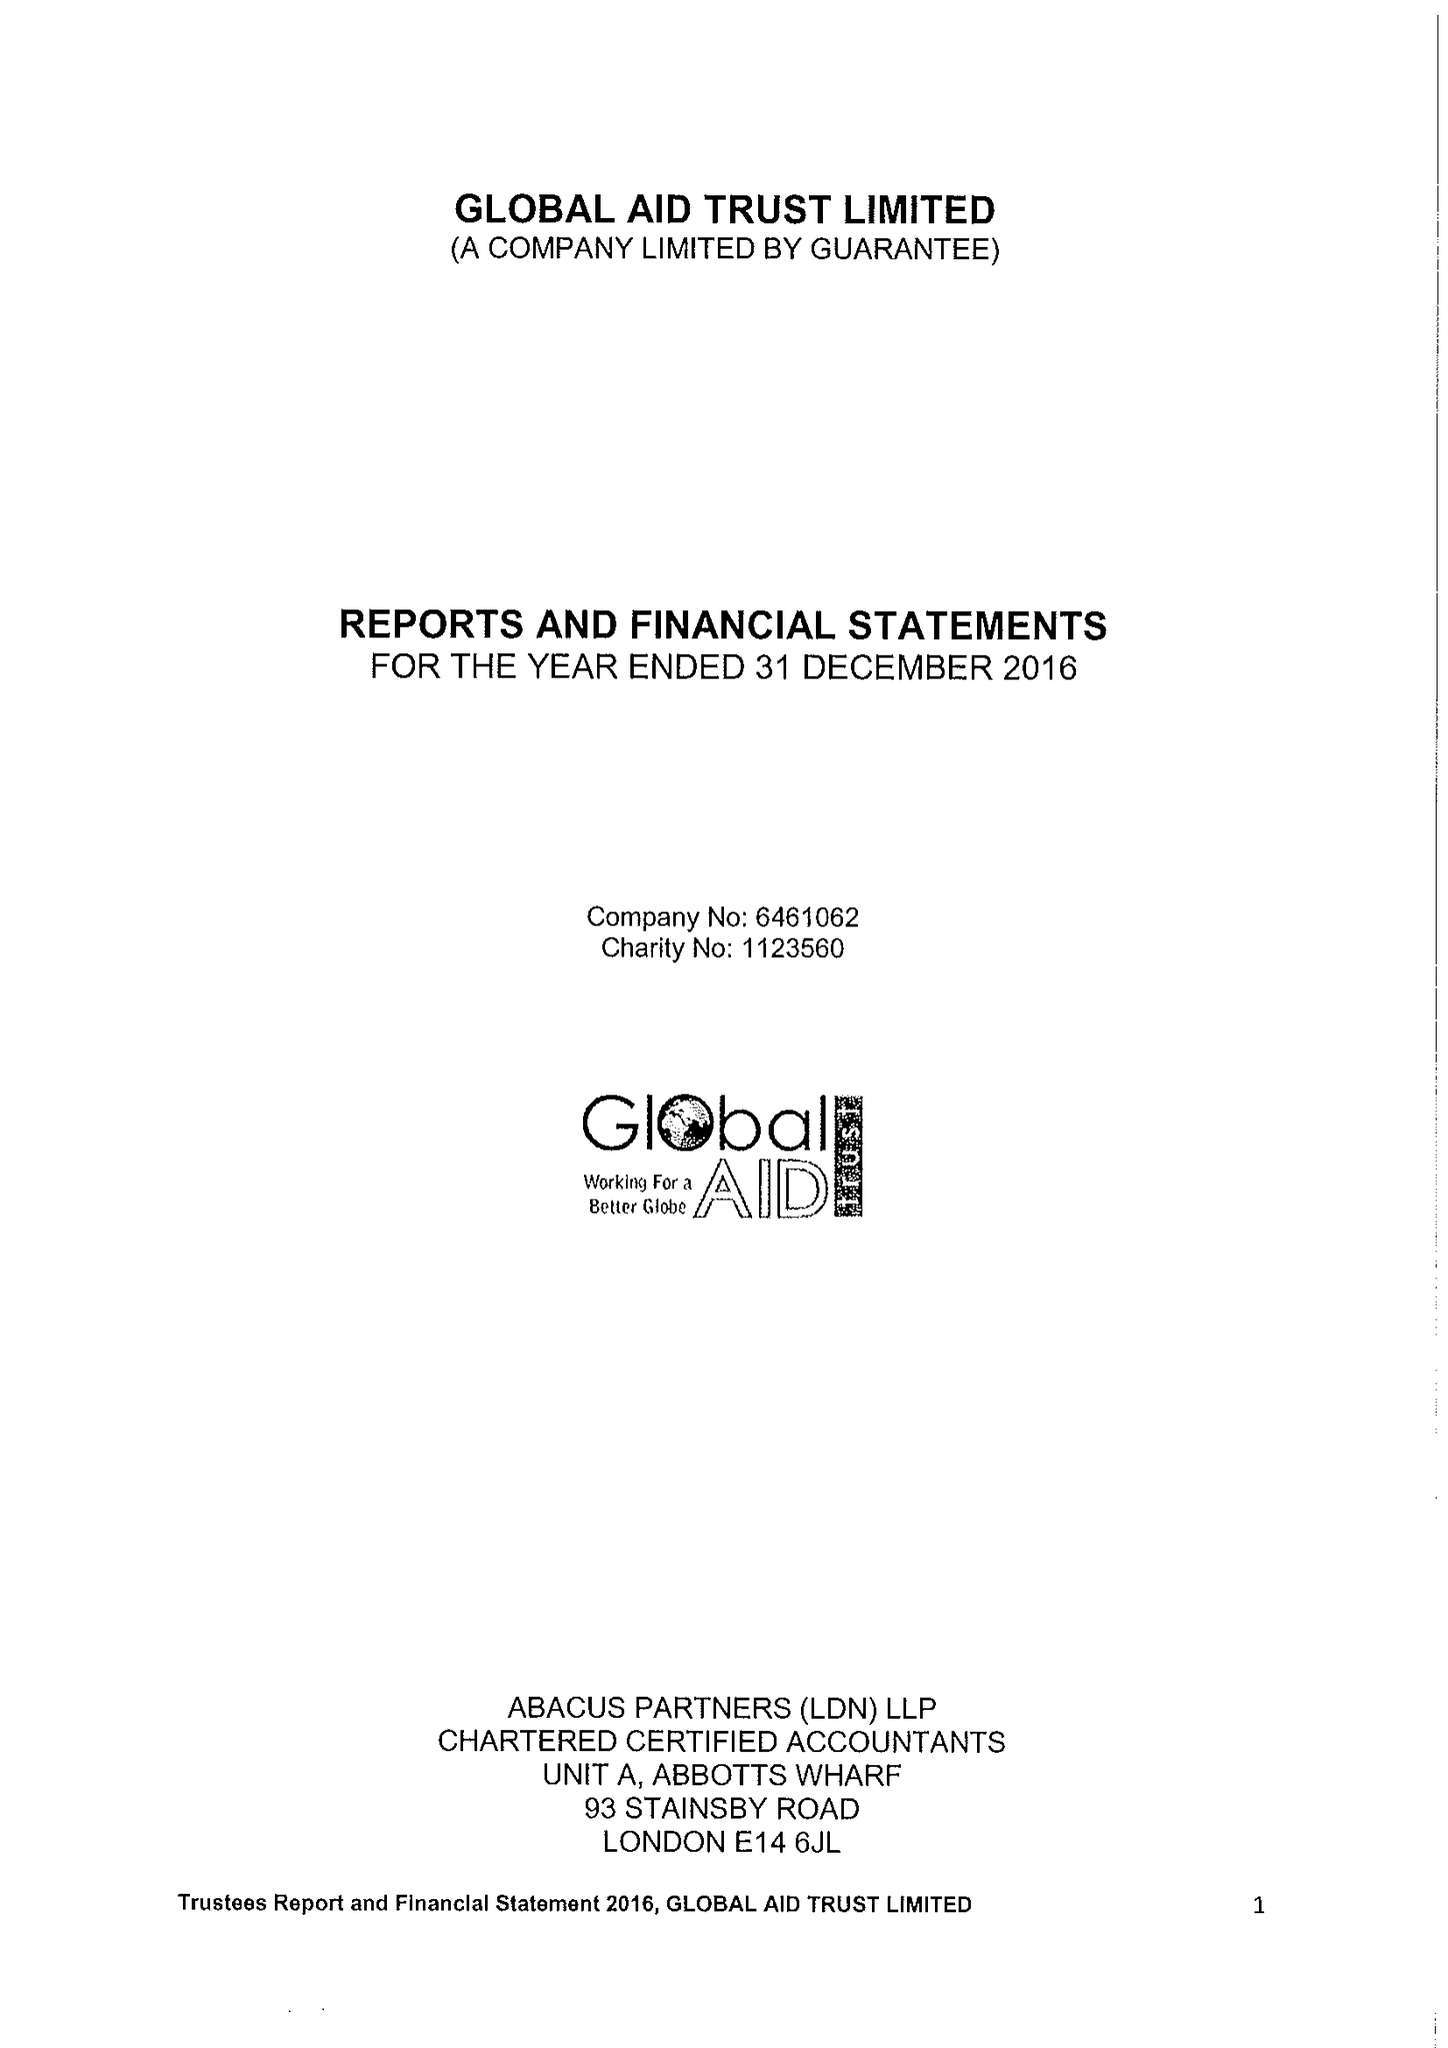What is the value for the address__postcode?
Answer the question using a single word or phrase. E1 2BJ 